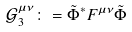Convert formula to latex. <formula><loc_0><loc_0><loc_500><loc_500>\mathcal { G } _ { 3 } ^ { \mu \nu } \colon = \tilde { \Phi } ^ { \ast } F ^ { \mu \nu } \tilde { \Phi }</formula> 